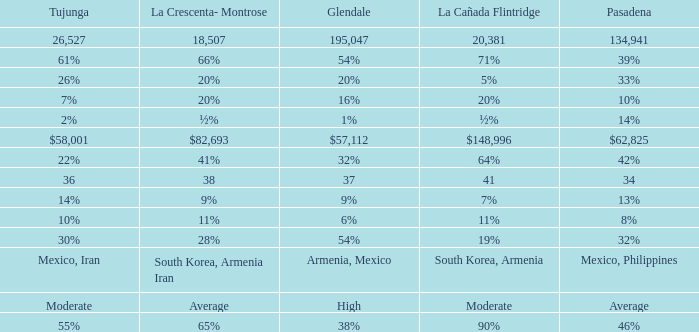If pasadena has a percentage of 14%, what is the percentage for glendale? 1%. 